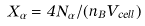<formula> <loc_0><loc_0><loc_500><loc_500>X _ { \alpha } = 4 N _ { \alpha } / ( n _ { B } V _ { c e l l } )</formula> 